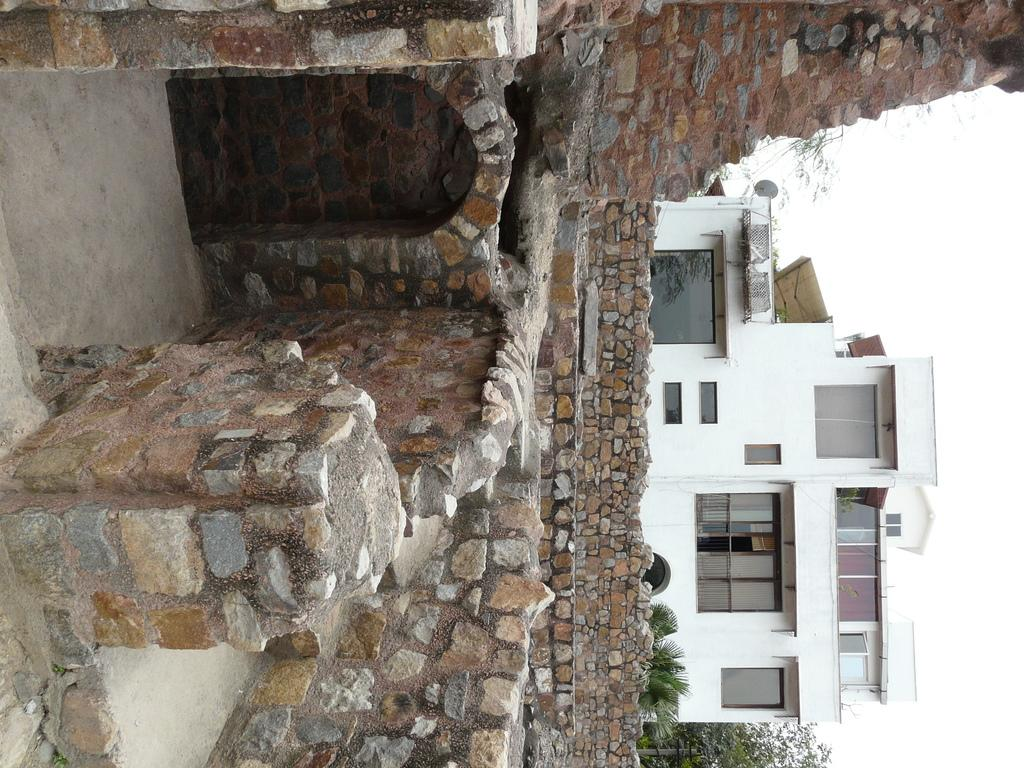What is the main subject in the center of the image? There is a stone structure in the center of the image. Can you describe the background of the image? There is a building in the background of the image. What type of rings can be seen on the writer's fingers in the image? There is no writer or rings present in the image; it features a stone structure and a building in the background. 